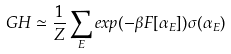<formula> <loc_0><loc_0><loc_500><loc_500>\ G H \simeq \frac { 1 } { Z } \sum _ { E } e x p ( - \beta F [ \alpha _ { E } ] ) \sigma ( \alpha _ { E } )</formula> 